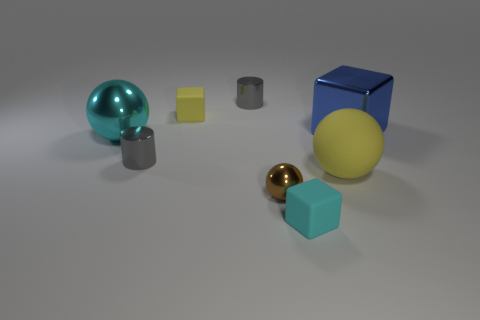Is there any other thing that has the same material as the tiny brown ball?
Ensure brevity in your answer.  Yes. Are there an equal number of blue objects that are in front of the cyan matte thing and small cubes behind the shiny cube?
Provide a succinct answer. No. Is the large yellow ball made of the same material as the tiny brown thing?
Provide a succinct answer. No. What number of cyan things are either big matte cylinders or matte spheres?
Keep it short and to the point. 0. How many other matte things are the same shape as the small brown thing?
Your response must be concise. 1. What is the tiny ball made of?
Provide a succinct answer. Metal. Are there the same number of small metallic balls in front of the small brown shiny thing and big red shiny cylinders?
Make the answer very short. Yes. The matte thing that is the same size as the cyan block is what shape?
Keep it short and to the point. Cube. There is a blue metallic thing behind the small brown metal object; are there any large cyan objects behind it?
Your answer should be compact. No. What number of big objects are either yellow rubber things or cyan metallic balls?
Your response must be concise. 2. 